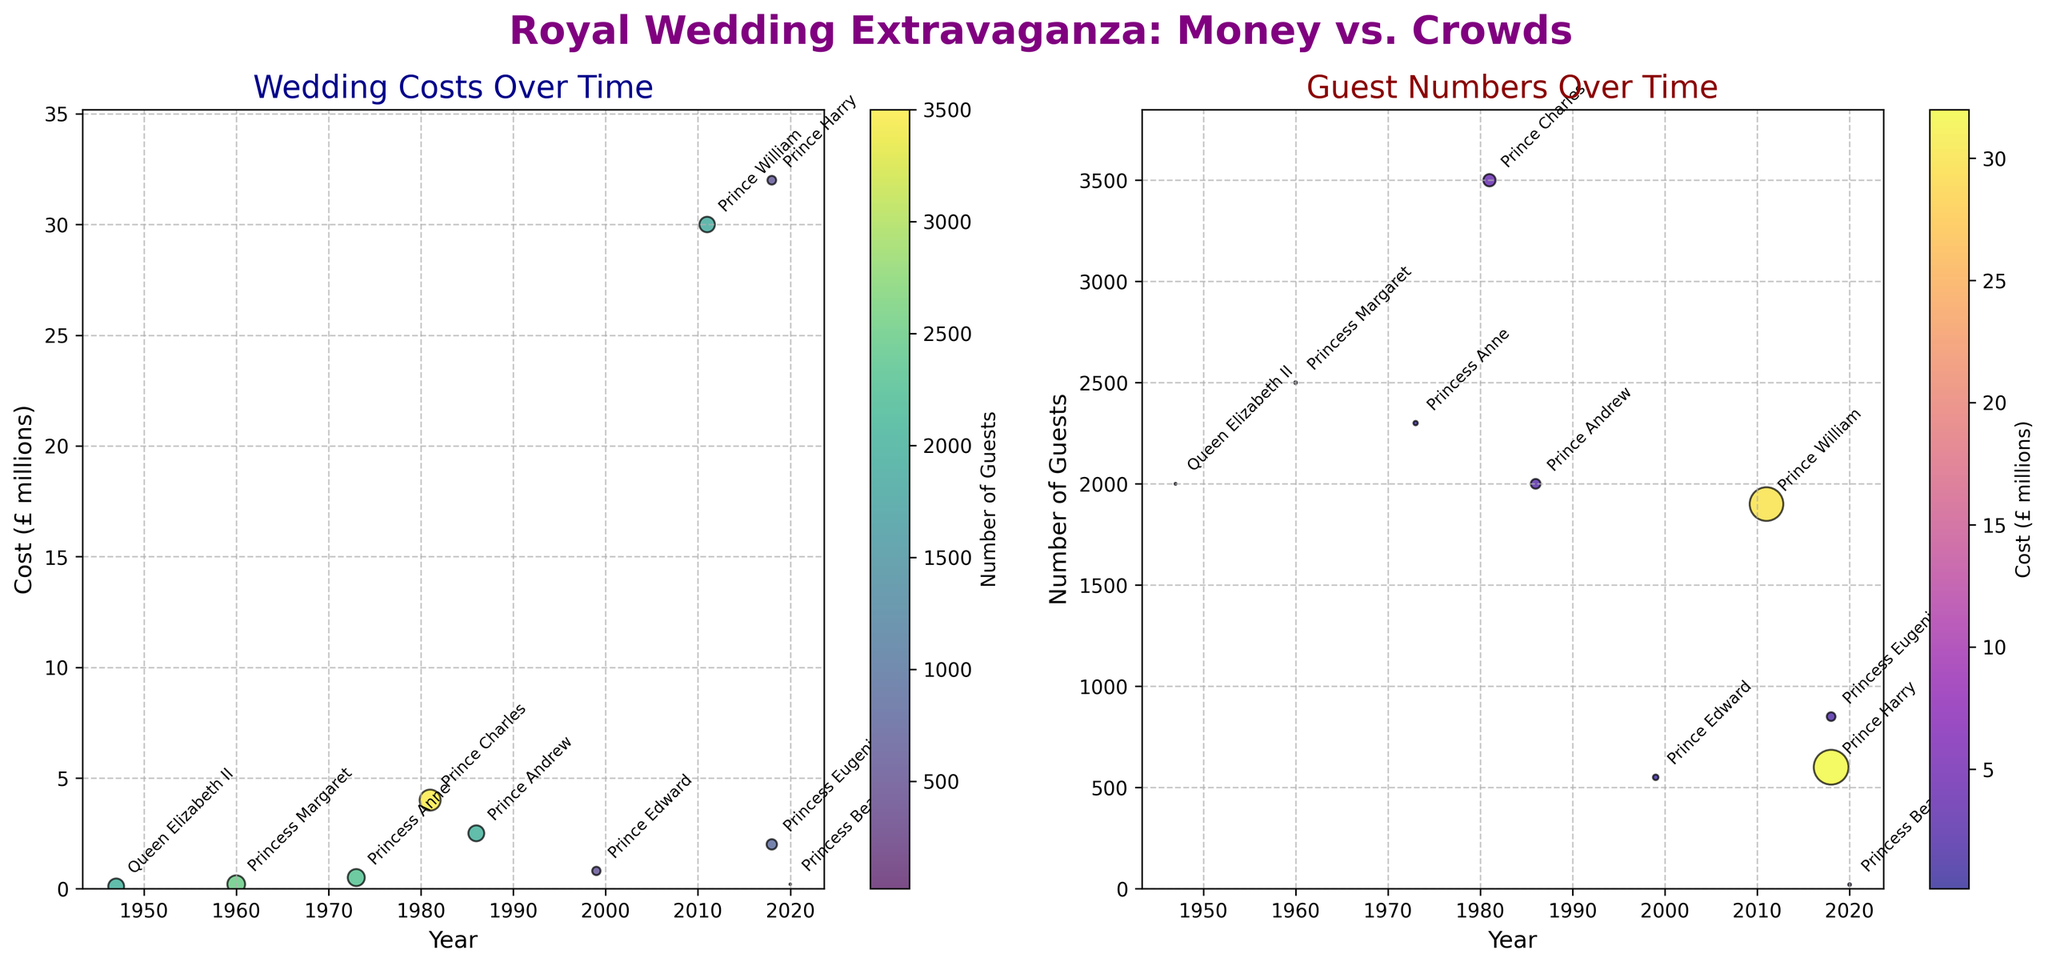Which wedding had the highest cost? From the 'Wedding Costs Over Time' scatter plot, the highest cost is around 32 million pounds, which is annotated as "Prince Harry's wedding".
Answer: Prince Harry & Meghan Markle How many guests attended Princess Margaret & Antony Armstrong-Jones's wedding? On the 'Guest Numbers Over Time' scatter plot, Princess Margaret's wedding is annotated around the 1960 mark with roughly 2500 guests.
Answer: 2500 Which wedding had the least number of guests? The data point with the smallest circle in the 'Guest Numbers Over Time' scatter plot is Princess Beatrice's wedding in 2020, noted to have only 20 guests.
Answer: Princess Beatrice & Edoardo Mapelli Mozzi What trend can be observed in wedding costs over time? Referring to the 'Wedding Costs Over Time' scatter plot, an upward trend in wedding expenses can be seen over the decades, peaking with Prince Harry's wedding in 2018.
Answer: Increasing trend Did any wedding have a large number of guests but relatively low cost? In the scatter plots, Princess Anne's wedding in 1973 stands out with around 2300 guests but a cost of only 0.5 million pounds.
Answer: Princess Anne & Mark Phillips How does the number of guests correlate with the cost in Prince Andrew's wedding? In both scatter plots, Prince Andrew's wedding in 1986 shows around 2000 guests and a cost of 2.5 million pounds. There's a moderate correlation where higher guests resulted in mid-range costs.
Answer: Moderate correlation Which wedding had the biggest difference between the number of guests and the wedding cost? Prince Harry's wedding in the 'Guest Numbers Over Time' scatter plot shows around 600 guests and a cost of 32 million pounds, the largest cost-to-guest ratio.
Answer: Prince Harry & Meghan Markle How have guest numbers changed over the years from Queen Elizabeth II's wedding to Prince Harry's wedding? The 'Guest Numbers Over Time' scatter plot indicates a general decrease in guests from 2000 in 1947 to around 600 in 2018, with notable fluctuations in-between.
Answer: Decrease with fluctuations Are there more weddings with fewer than 1000 guests or more than 1000 guests? In the 'Guest Numbers Over Time' scatter plot, there are more circles above the 1000 guests mark, indicating most weddings had over 1000 guests.
Answer: More than 1000 guests 